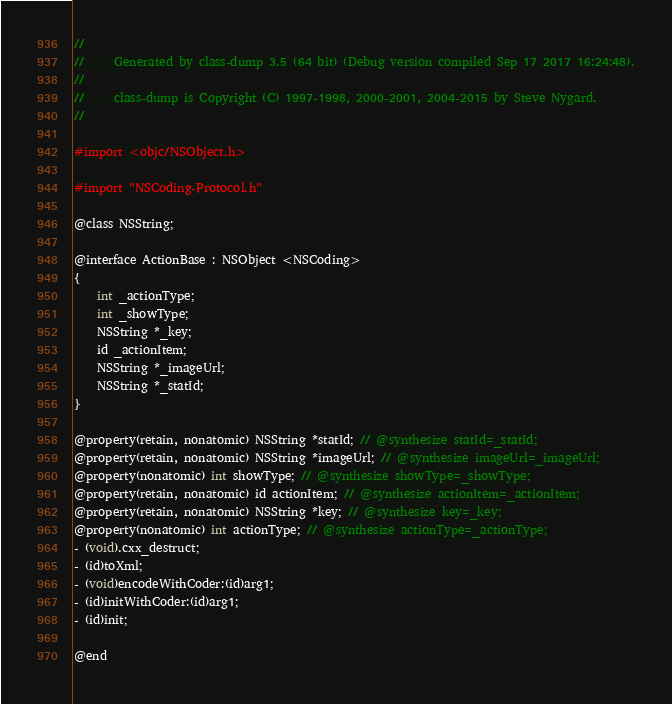<code> <loc_0><loc_0><loc_500><loc_500><_C_>//
//     Generated by class-dump 3.5 (64 bit) (Debug version compiled Sep 17 2017 16:24:48).
//
//     class-dump is Copyright (C) 1997-1998, 2000-2001, 2004-2015 by Steve Nygard.
//

#import <objc/NSObject.h>

#import "NSCoding-Protocol.h"

@class NSString;

@interface ActionBase : NSObject <NSCoding>
{
    int _actionType;
    int _showType;
    NSString *_key;
    id _actionItem;
    NSString *_imageUrl;
    NSString *_statId;
}

@property(retain, nonatomic) NSString *statId; // @synthesize statId=_statId;
@property(retain, nonatomic) NSString *imageUrl; // @synthesize imageUrl=_imageUrl;
@property(nonatomic) int showType; // @synthesize showType=_showType;
@property(retain, nonatomic) id actionItem; // @synthesize actionItem=_actionItem;
@property(retain, nonatomic) NSString *key; // @synthesize key=_key;
@property(nonatomic) int actionType; // @synthesize actionType=_actionType;
- (void).cxx_destruct;
- (id)toXml;
- (void)encodeWithCoder:(id)arg1;
- (id)initWithCoder:(id)arg1;
- (id)init;

@end

</code> 